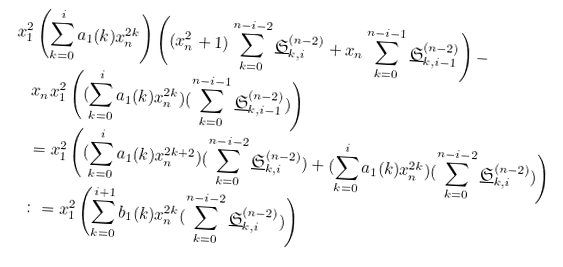Convert formula to latex. <formula><loc_0><loc_0><loc_500><loc_500>x _ { 1 } ^ { 2 } & \left ( \sum _ { k = 0 } ^ { i } a _ { 1 } ( k ) x _ { n } ^ { 2 k } \right ) \left ( ( x _ { n } ^ { 2 } + 1 ) \sum _ { k = 0 } ^ { n - i - 2 } \underline { \mathfrak { S } } ^ { ( n - 2 ) } _ { k , i } + x _ { n } \sum _ { k = 0 } ^ { n - i - 1 } \underline { \mathfrak { S } } ^ { ( n - 2 ) } _ { k , i - 1 } \right ) - \\ & x _ { n } x _ { 1 } ^ { 2 } \left ( ( \sum _ { k = 0 } ^ { i } a _ { 1 } ( k ) x _ { n } ^ { 2 k } ) ( \sum _ { k = 0 } ^ { n - i - 1 } \underline { \mathfrak { S } } ^ { ( n - 2 ) } _ { k , i - 1 } ) \right ) \\ & = x _ { 1 } ^ { 2 } \left ( ( \sum _ { k = 0 } ^ { i } a _ { 1 } ( k ) x _ { n } ^ { 2 k + 2 } ) ( \sum _ { k = 0 } ^ { n - i - 2 } \underline { \mathfrak { S } } ^ { ( n - 2 ) } _ { k , i } ) + ( \sum _ { k = 0 } ^ { i } a _ { 1 } ( k ) x _ { n } ^ { 2 k } ) ( \sum _ { k = 0 } ^ { n - i - 2 } \underline { \mathfrak { S } } ^ { ( n - 2 ) } _ { k , i } ) \right ) \\ & \colon = x _ { 1 } ^ { 2 } \left ( \sum _ { k = 0 } ^ { i + 1 } b _ { 1 } ( k ) x _ { n } ^ { 2 k } ( \sum _ { k = 0 } ^ { n - i - 2 } \underline { \mathfrak { S } } ^ { ( n - 2 ) } _ { k , i } ) \right )</formula> 